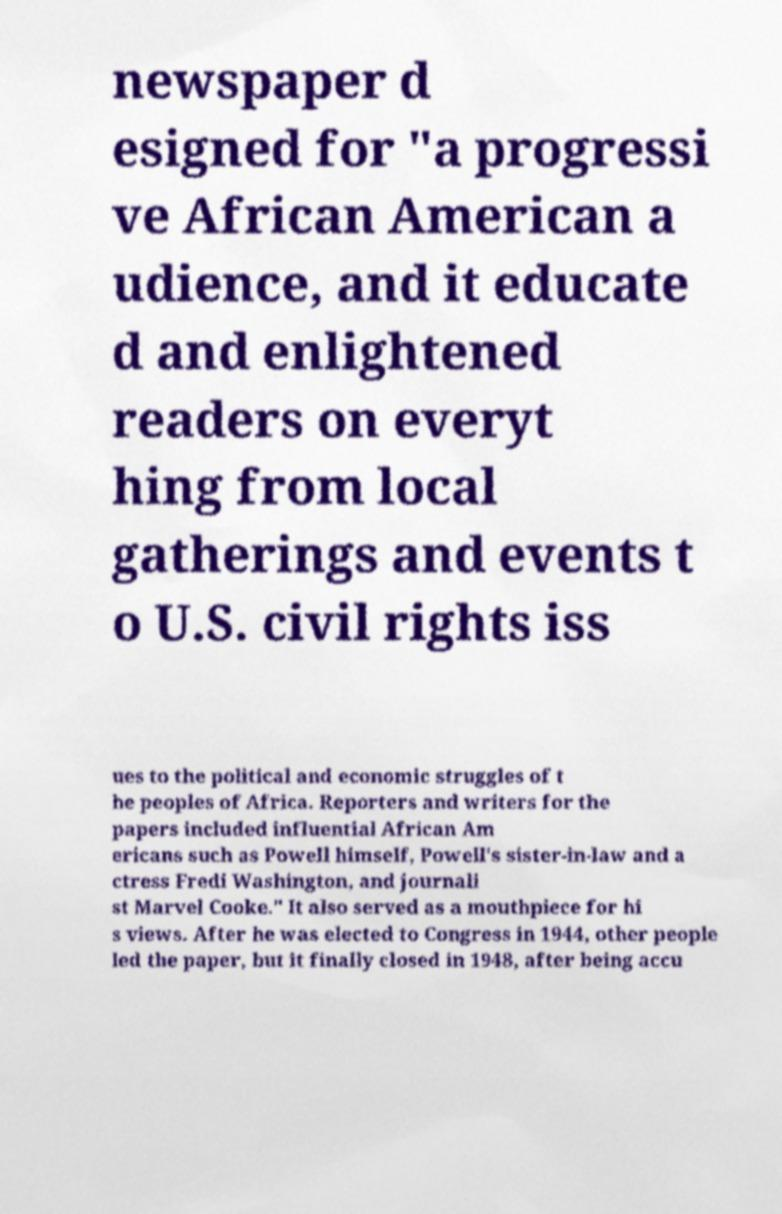I need the written content from this picture converted into text. Can you do that? newspaper d esigned for "a progressi ve African American a udience, and it educate d and enlightened readers on everyt hing from local gatherings and events t o U.S. civil rights iss ues to the political and economic struggles of t he peoples of Africa. Reporters and writers for the papers included influential African Am ericans such as Powell himself, Powell's sister-in-law and a ctress Fredi Washington, and journali st Marvel Cooke." It also served as a mouthpiece for hi s views. After he was elected to Congress in 1944, other people led the paper, but it finally closed in 1948, after being accu 